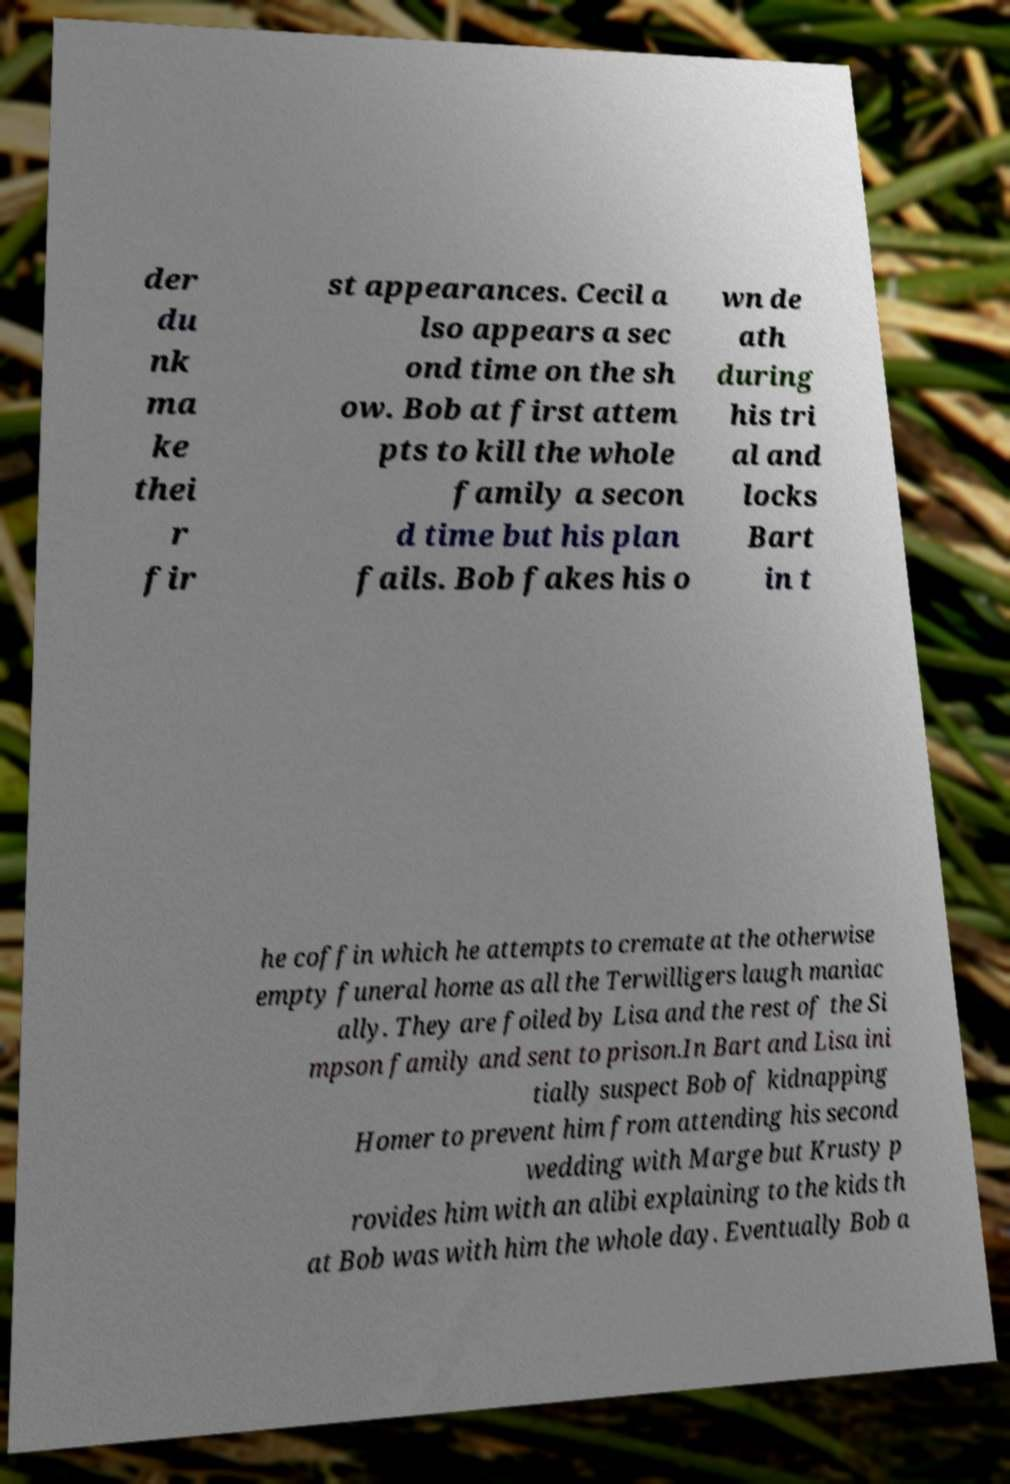Please identify and transcribe the text found in this image. der du nk ma ke thei r fir st appearances. Cecil a lso appears a sec ond time on the sh ow. Bob at first attem pts to kill the whole family a secon d time but his plan fails. Bob fakes his o wn de ath during his tri al and locks Bart in t he coffin which he attempts to cremate at the otherwise empty funeral home as all the Terwilligers laugh maniac ally. They are foiled by Lisa and the rest of the Si mpson family and sent to prison.In Bart and Lisa ini tially suspect Bob of kidnapping Homer to prevent him from attending his second wedding with Marge but Krusty p rovides him with an alibi explaining to the kids th at Bob was with him the whole day. Eventually Bob a 